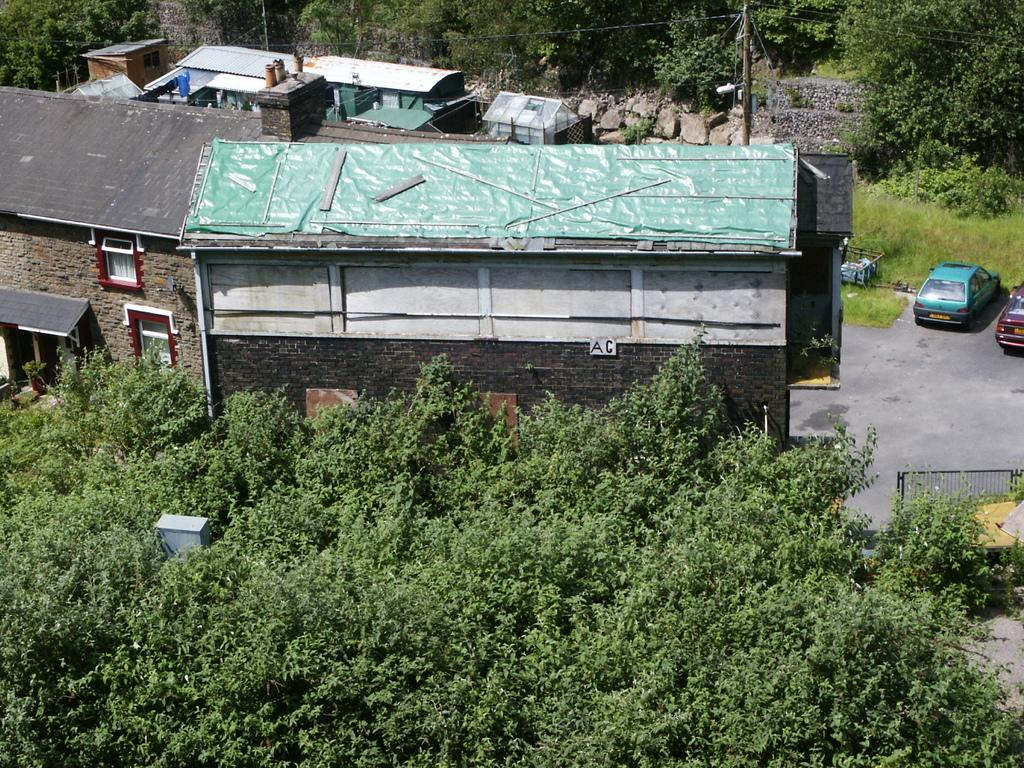What type of structures can be seen in the image? There are buildings and houses in the image. What vehicles are parked in the image? Cars are parked in the image. What type of vegetation is present in the image? Trees are present in the image. What type of ground cover is visible in the image? Grass is visible on the ground in the image. What type of clock is hanging on the tree in the image? There is no clock present in the image; it only features buildings, houses, cars, trees, and grass. What religious symbols can be seen in the image? There are no religious symbols present in the image. 